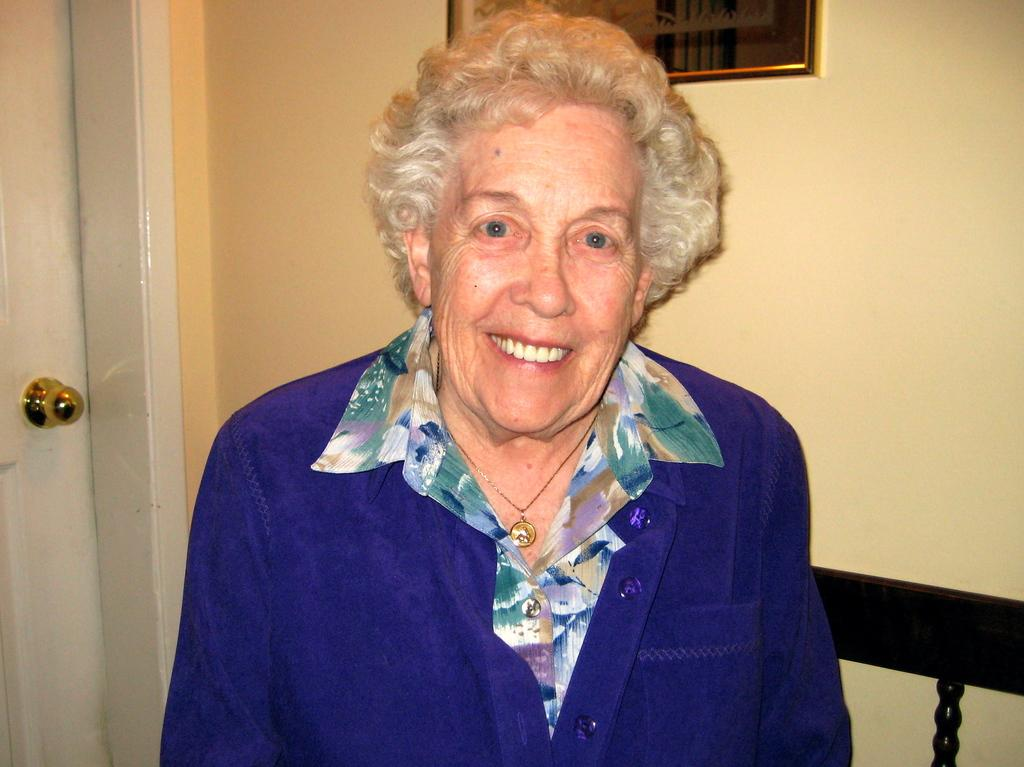Who is present in the image? There is a woman in the image. What is the woman wearing? The woman is wearing a blue coat. What is the woman doing in the image? The woman appears to be sitting on a bench. What can be seen on the wall in the background? There is a frame on the wall in the background. What architectural feature is visible in the background? There is a door in the background. What type of volleyball is being played in the image? There is no volleyball present in the image. How does the quartz contribute to the comfort of the bench? There is no quartz mentioned in the image, and the comfort of the bench is not discussed. 